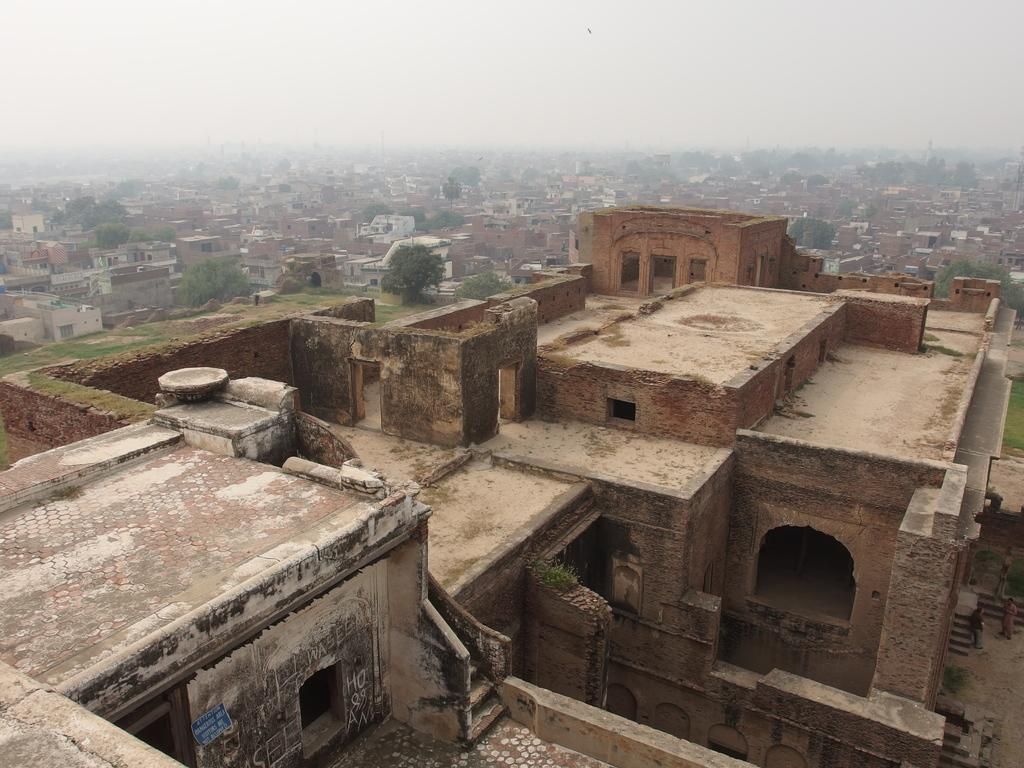What type of structures can be seen in the image? There are buildings in the image. What other natural elements are present in the image? There are trees in the image. What can be seen in the background of the image? The sky is visible in the background of the image. What current theory is being discussed in the image? There is no discussion or indication of any scientific theory in the image; it simply shows buildings, trees, and the sky. 